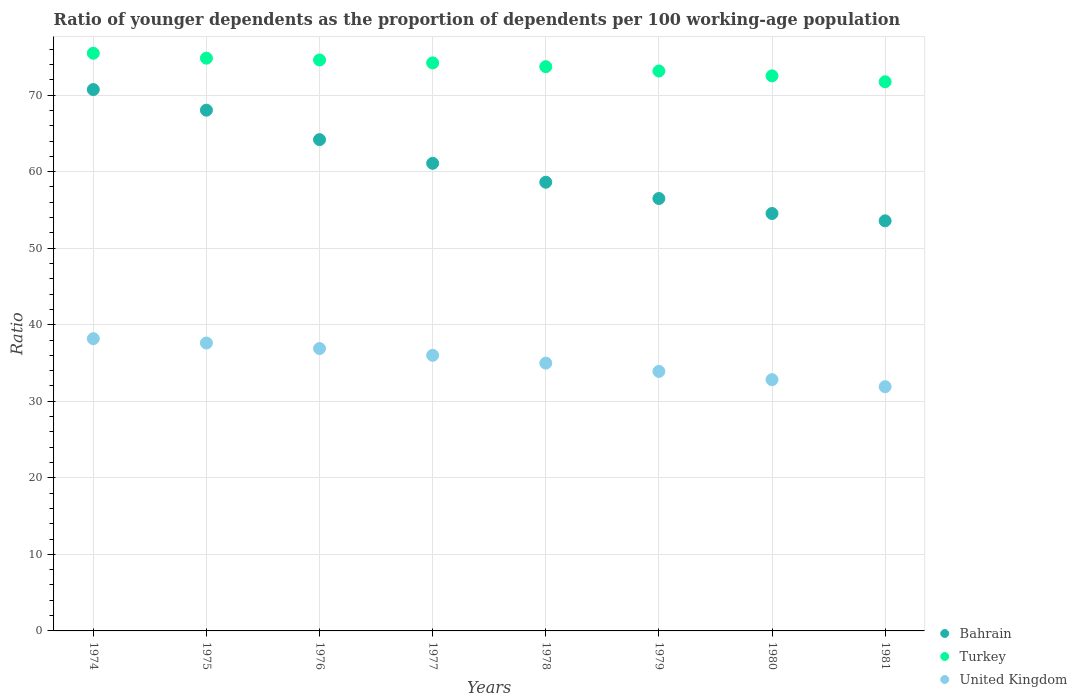How many different coloured dotlines are there?
Ensure brevity in your answer.  3. What is the age dependency ratio(young) in United Kingdom in 1981?
Make the answer very short. 31.91. Across all years, what is the maximum age dependency ratio(young) in Bahrain?
Provide a succinct answer. 70.73. Across all years, what is the minimum age dependency ratio(young) in Bahrain?
Ensure brevity in your answer.  53.58. In which year was the age dependency ratio(young) in Bahrain maximum?
Your answer should be compact. 1974. What is the total age dependency ratio(young) in Turkey in the graph?
Make the answer very short. 590.27. What is the difference between the age dependency ratio(young) in Turkey in 1976 and that in 1978?
Offer a very short reply. 0.87. What is the difference between the age dependency ratio(young) in United Kingdom in 1975 and the age dependency ratio(young) in Bahrain in 1977?
Your answer should be compact. -23.48. What is the average age dependency ratio(young) in Turkey per year?
Keep it short and to the point. 73.78. In the year 1981, what is the difference between the age dependency ratio(young) in Bahrain and age dependency ratio(young) in United Kingdom?
Your answer should be very brief. 21.67. What is the ratio of the age dependency ratio(young) in United Kingdom in 1975 to that in 1981?
Your answer should be compact. 1.18. Is the age dependency ratio(young) in United Kingdom in 1978 less than that in 1980?
Your response must be concise. No. What is the difference between the highest and the second highest age dependency ratio(young) in Turkey?
Offer a terse response. 0.64. What is the difference between the highest and the lowest age dependency ratio(young) in Bahrain?
Provide a short and direct response. 17.15. Is it the case that in every year, the sum of the age dependency ratio(young) in Turkey and age dependency ratio(young) in Bahrain  is greater than the age dependency ratio(young) in United Kingdom?
Provide a short and direct response. Yes. Does the age dependency ratio(young) in United Kingdom monotonically increase over the years?
Your answer should be very brief. No. Is the age dependency ratio(young) in Turkey strictly less than the age dependency ratio(young) in United Kingdom over the years?
Provide a short and direct response. No. How many dotlines are there?
Provide a short and direct response. 3. What is the difference between two consecutive major ticks on the Y-axis?
Your response must be concise. 10. Are the values on the major ticks of Y-axis written in scientific E-notation?
Make the answer very short. No. Where does the legend appear in the graph?
Your answer should be very brief. Bottom right. What is the title of the graph?
Make the answer very short. Ratio of younger dependents as the proportion of dependents per 100 working-age population. What is the label or title of the X-axis?
Ensure brevity in your answer.  Years. What is the label or title of the Y-axis?
Your answer should be compact. Ratio. What is the Ratio of Bahrain in 1974?
Your response must be concise. 70.73. What is the Ratio in Turkey in 1974?
Your answer should be very brief. 75.48. What is the Ratio in United Kingdom in 1974?
Make the answer very short. 38.18. What is the Ratio of Bahrain in 1975?
Provide a succinct answer. 68.04. What is the Ratio in Turkey in 1975?
Ensure brevity in your answer.  74.83. What is the Ratio of United Kingdom in 1975?
Provide a short and direct response. 37.62. What is the Ratio in Bahrain in 1976?
Your answer should be very brief. 64.19. What is the Ratio of Turkey in 1976?
Offer a terse response. 74.6. What is the Ratio of United Kingdom in 1976?
Your answer should be compact. 36.89. What is the Ratio of Bahrain in 1977?
Your answer should be very brief. 61.09. What is the Ratio in Turkey in 1977?
Offer a terse response. 74.21. What is the Ratio in United Kingdom in 1977?
Offer a very short reply. 36.01. What is the Ratio in Bahrain in 1978?
Your response must be concise. 58.62. What is the Ratio in Turkey in 1978?
Offer a terse response. 73.72. What is the Ratio of United Kingdom in 1978?
Offer a terse response. 34.99. What is the Ratio of Bahrain in 1979?
Provide a succinct answer. 56.5. What is the Ratio in Turkey in 1979?
Ensure brevity in your answer.  73.16. What is the Ratio of United Kingdom in 1979?
Your response must be concise. 33.9. What is the Ratio of Bahrain in 1980?
Give a very brief answer. 54.54. What is the Ratio of Turkey in 1980?
Give a very brief answer. 72.52. What is the Ratio of United Kingdom in 1980?
Offer a terse response. 32.83. What is the Ratio in Bahrain in 1981?
Provide a succinct answer. 53.58. What is the Ratio of Turkey in 1981?
Your answer should be compact. 71.75. What is the Ratio in United Kingdom in 1981?
Provide a short and direct response. 31.91. Across all years, what is the maximum Ratio in Bahrain?
Keep it short and to the point. 70.73. Across all years, what is the maximum Ratio in Turkey?
Provide a succinct answer. 75.48. Across all years, what is the maximum Ratio in United Kingdom?
Make the answer very short. 38.18. Across all years, what is the minimum Ratio of Bahrain?
Provide a short and direct response. 53.58. Across all years, what is the minimum Ratio of Turkey?
Your response must be concise. 71.75. Across all years, what is the minimum Ratio in United Kingdom?
Give a very brief answer. 31.91. What is the total Ratio in Bahrain in the graph?
Offer a terse response. 487.29. What is the total Ratio in Turkey in the graph?
Offer a very short reply. 590.27. What is the total Ratio of United Kingdom in the graph?
Offer a very short reply. 282.34. What is the difference between the Ratio in Bahrain in 1974 and that in 1975?
Your answer should be compact. 2.69. What is the difference between the Ratio of Turkey in 1974 and that in 1975?
Provide a succinct answer. 0.64. What is the difference between the Ratio of United Kingdom in 1974 and that in 1975?
Offer a terse response. 0.57. What is the difference between the Ratio in Bahrain in 1974 and that in 1976?
Provide a short and direct response. 6.54. What is the difference between the Ratio in Turkey in 1974 and that in 1976?
Ensure brevity in your answer.  0.88. What is the difference between the Ratio of United Kingdom in 1974 and that in 1976?
Keep it short and to the point. 1.29. What is the difference between the Ratio of Bahrain in 1974 and that in 1977?
Provide a short and direct response. 9.64. What is the difference between the Ratio of Turkey in 1974 and that in 1977?
Provide a succinct answer. 1.26. What is the difference between the Ratio of United Kingdom in 1974 and that in 1977?
Keep it short and to the point. 2.17. What is the difference between the Ratio of Bahrain in 1974 and that in 1978?
Ensure brevity in your answer.  12.11. What is the difference between the Ratio in Turkey in 1974 and that in 1978?
Offer a terse response. 1.75. What is the difference between the Ratio in United Kingdom in 1974 and that in 1978?
Make the answer very short. 3.19. What is the difference between the Ratio of Bahrain in 1974 and that in 1979?
Your answer should be compact. 14.24. What is the difference between the Ratio of Turkey in 1974 and that in 1979?
Ensure brevity in your answer.  2.32. What is the difference between the Ratio of United Kingdom in 1974 and that in 1979?
Your answer should be compact. 4.28. What is the difference between the Ratio in Bahrain in 1974 and that in 1980?
Your answer should be very brief. 16.19. What is the difference between the Ratio in Turkey in 1974 and that in 1980?
Your answer should be compact. 2.95. What is the difference between the Ratio of United Kingdom in 1974 and that in 1980?
Make the answer very short. 5.35. What is the difference between the Ratio in Bahrain in 1974 and that in 1981?
Offer a terse response. 17.15. What is the difference between the Ratio of Turkey in 1974 and that in 1981?
Your response must be concise. 3.73. What is the difference between the Ratio of United Kingdom in 1974 and that in 1981?
Your response must be concise. 6.28. What is the difference between the Ratio of Bahrain in 1975 and that in 1976?
Offer a very short reply. 3.85. What is the difference between the Ratio of Turkey in 1975 and that in 1976?
Your response must be concise. 0.23. What is the difference between the Ratio of United Kingdom in 1975 and that in 1976?
Provide a succinct answer. 0.72. What is the difference between the Ratio of Bahrain in 1975 and that in 1977?
Offer a terse response. 6.94. What is the difference between the Ratio of Turkey in 1975 and that in 1977?
Your answer should be compact. 0.62. What is the difference between the Ratio of United Kingdom in 1975 and that in 1977?
Ensure brevity in your answer.  1.6. What is the difference between the Ratio in Bahrain in 1975 and that in 1978?
Provide a succinct answer. 9.41. What is the difference between the Ratio in Turkey in 1975 and that in 1978?
Provide a short and direct response. 1.11. What is the difference between the Ratio of United Kingdom in 1975 and that in 1978?
Keep it short and to the point. 2.63. What is the difference between the Ratio in Bahrain in 1975 and that in 1979?
Offer a very short reply. 11.54. What is the difference between the Ratio of Turkey in 1975 and that in 1979?
Ensure brevity in your answer.  1.67. What is the difference between the Ratio in United Kingdom in 1975 and that in 1979?
Make the answer very short. 3.71. What is the difference between the Ratio in Bahrain in 1975 and that in 1980?
Make the answer very short. 13.5. What is the difference between the Ratio in Turkey in 1975 and that in 1980?
Your answer should be compact. 2.31. What is the difference between the Ratio in United Kingdom in 1975 and that in 1980?
Ensure brevity in your answer.  4.79. What is the difference between the Ratio in Bahrain in 1975 and that in 1981?
Your answer should be very brief. 14.46. What is the difference between the Ratio of Turkey in 1975 and that in 1981?
Offer a very short reply. 3.08. What is the difference between the Ratio of United Kingdom in 1975 and that in 1981?
Your answer should be compact. 5.71. What is the difference between the Ratio of Bahrain in 1976 and that in 1977?
Give a very brief answer. 3.09. What is the difference between the Ratio of Turkey in 1976 and that in 1977?
Your response must be concise. 0.38. What is the difference between the Ratio in United Kingdom in 1976 and that in 1977?
Provide a succinct answer. 0.88. What is the difference between the Ratio in Bahrain in 1976 and that in 1978?
Your answer should be very brief. 5.56. What is the difference between the Ratio of Turkey in 1976 and that in 1978?
Provide a short and direct response. 0.87. What is the difference between the Ratio in United Kingdom in 1976 and that in 1978?
Make the answer very short. 1.9. What is the difference between the Ratio of Bahrain in 1976 and that in 1979?
Your answer should be compact. 7.69. What is the difference between the Ratio in Turkey in 1976 and that in 1979?
Offer a very short reply. 1.44. What is the difference between the Ratio of United Kingdom in 1976 and that in 1979?
Provide a short and direct response. 2.99. What is the difference between the Ratio of Bahrain in 1976 and that in 1980?
Make the answer very short. 9.65. What is the difference between the Ratio in Turkey in 1976 and that in 1980?
Make the answer very short. 2.08. What is the difference between the Ratio of United Kingdom in 1976 and that in 1980?
Make the answer very short. 4.06. What is the difference between the Ratio of Bahrain in 1976 and that in 1981?
Give a very brief answer. 10.61. What is the difference between the Ratio of Turkey in 1976 and that in 1981?
Offer a terse response. 2.85. What is the difference between the Ratio of United Kingdom in 1976 and that in 1981?
Ensure brevity in your answer.  4.99. What is the difference between the Ratio in Bahrain in 1977 and that in 1978?
Your answer should be very brief. 2.47. What is the difference between the Ratio of Turkey in 1977 and that in 1978?
Give a very brief answer. 0.49. What is the difference between the Ratio of United Kingdom in 1977 and that in 1978?
Give a very brief answer. 1.02. What is the difference between the Ratio of Bahrain in 1977 and that in 1979?
Your answer should be very brief. 4.6. What is the difference between the Ratio in Turkey in 1977 and that in 1979?
Your answer should be very brief. 1.06. What is the difference between the Ratio in United Kingdom in 1977 and that in 1979?
Your answer should be very brief. 2.11. What is the difference between the Ratio in Bahrain in 1977 and that in 1980?
Offer a very short reply. 6.56. What is the difference between the Ratio in Turkey in 1977 and that in 1980?
Your answer should be very brief. 1.69. What is the difference between the Ratio in United Kingdom in 1977 and that in 1980?
Ensure brevity in your answer.  3.18. What is the difference between the Ratio in Bahrain in 1977 and that in 1981?
Keep it short and to the point. 7.51. What is the difference between the Ratio in Turkey in 1977 and that in 1981?
Offer a very short reply. 2.46. What is the difference between the Ratio of United Kingdom in 1977 and that in 1981?
Provide a short and direct response. 4.1. What is the difference between the Ratio of Bahrain in 1978 and that in 1979?
Your response must be concise. 2.13. What is the difference between the Ratio in Turkey in 1978 and that in 1979?
Keep it short and to the point. 0.57. What is the difference between the Ratio in United Kingdom in 1978 and that in 1979?
Give a very brief answer. 1.09. What is the difference between the Ratio of Bahrain in 1978 and that in 1980?
Offer a very short reply. 4.09. What is the difference between the Ratio in Turkey in 1978 and that in 1980?
Keep it short and to the point. 1.2. What is the difference between the Ratio in United Kingdom in 1978 and that in 1980?
Provide a succinct answer. 2.16. What is the difference between the Ratio of Bahrain in 1978 and that in 1981?
Make the answer very short. 5.04. What is the difference between the Ratio of Turkey in 1978 and that in 1981?
Your answer should be very brief. 1.97. What is the difference between the Ratio of United Kingdom in 1978 and that in 1981?
Provide a succinct answer. 3.08. What is the difference between the Ratio of Bahrain in 1979 and that in 1980?
Provide a short and direct response. 1.96. What is the difference between the Ratio of Turkey in 1979 and that in 1980?
Offer a very short reply. 0.64. What is the difference between the Ratio of United Kingdom in 1979 and that in 1980?
Provide a succinct answer. 1.07. What is the difference between the Ratio in Bahrain in 1979 and that in 1981?
Your answer should be compact. 2.91. What is the difference between the Ratio in Turkey in 1979 and that in 1981?
Give a very brief answer. 1.41. What is the difference between the Ratio in United Kingdom in 1979 and that in 1981?
Provide a succinct answer. 2. What is the difference between the Ratio in Bahrain in 1980 and that in 1981?
Your response must be concise. 0.96. What is the difference between the Ratio in Turkey in 1980 and that in 1981?
Your response must be concise. 0.77. What is the difference between the Ratio in United Kingdom in 1980 and that in 1981?
Provide a short and direct response. 0.92. What is the difference between the Ratio of Bahrain in 1974 and the Ratio of Turkey in 1975?
Ensure brevity in your answer.  -4.1. What is the difference between the Ratio in Bahrain in 1974 and the Ratio in United Kingdom in 1975?
Provide a succinct answer. 33.12. What is the difference between the Ratio of Turkey in 1974 and the Ratio of United Kingdom in 1975?
Keep it short and to the point. 37.86. What is the difference between the Ratio in Bahrain in 1974 and the Ratio in Turkey in 1976?
Offer a very short reply. -3.87. What is the difference between the Ratio of Bahrain in 1974 and the Ratio of United Kingdom in 1976?
Provide a succinct answer. 33.84. What is the difference between the Ratio in Turkey in 1974 and the Ratio in United Kingdom in 1976?
Make the answer very short. 38.58. What is the difference between the Ratio of Bahrain in 1974 and the Ratio of Turkey in 1977?
Your answer should be compact. -3.48. What is the difference between the Ratio of Bahrain in 1974 and the Ratio of United Kingdom in 1977?
Provide a short and direct response. 34.72. What is the difference between the Ratio in Turkey in 1974 and the Ratio in United Kingdom in 1977?
Give a very brief answer. 39.46. What is the difference between the Ratio of Bahrain in 1974 and the Ratio of Turkey in 1978?
Offer a very short reply. -2.99. What is the difference between the Ratio of Bahrain in 1974 and the Ratio of United Kingdom in 1978?
Offer a terse response. 35.74. What is the difference between the Ratio of Turkey in 1974 and the Ratio of United Kingdom in 1978?
Your answer should be very brief. 40.48. What is the difference between the Ratio of Bahrain in 1974 and the Ratio of Turkey in 1979?
Provide a succinct answer. -2.42. What is the difference between the Ratio in Bahrain in 1974 and the Ratio in United Kingdom in 1979?
Your answer should be very brief. 36.83. What is the difference between the Ratio in Turkey in 1974 and the Ratio in United Kingdom in 1979?
Keep it short and to the point. 41.57. What is the difference between the Ratio of Bahrain in 1974 and the Ratio of Turkey in 1980?
Offer a very short reply. -1.79. What is the difference between the Ratio in Bahrain in 1974 and the Ratio in United Kingdom in 1980?
Provide a short and direct response. 37.9. What is the difference between the Ratio of Turkey in 1974 and the Ratio of United Kingdom in 1980?
Your answer should be very brief. 42.65. What is the difference between the Ratio in Bahrain in 1974 and the Ratio in Turkey in 1981?
Provide a short and direct response. -1.02. What is the difference between the Ratio of Bahrain in 1974 and the Ratio of United Kingdom in 1981?
Offer a terse response. 38.82. What is the difference between the Ratio of Turkey in 1974 and the Ratio of United Kingdom in 1981?
Make the answer very short. 43.57. What is the difference between the Ratio in Bahrain in 1975 and the Ratio in Turkey in 1976?
Provide a succinct answer. -6.56. What is the difference between the Ratio of Bahrain in 1975 and the Ratio of United Kingdom in 1976?
Give a very brief answer. 31.15. What is the difference between the Ratio of Turkey in 1975 and the Ratio of United Kingdom in 1976?
Your answer should be compact. 37.94. What is the difference between the Ratio of Bahrain in 1975 and the Ratio of Turkey in 1977?
Keep it short and to the point. -6.17. What is the difference between the Ratio in Bahrain in 1975 and the Ratio in United Kingdom in 1977?
Provide a short and direct response. 32.03. What is the difference between the Ratio in Turkey in 1975 and the Ratio in United Kingdom in 1977?
Offer a terse response. 38.82. What is the difference between the Ratio in Bahrain in 1975 and the Ratio in Turkey in 1978?
Ensure brevity in your answer.  -5.68. What is the difference between the Ratio of Bahrain in 1975 and the Ratio of United Kingdom in 1978?
Ensure brevity in your answer.  33.05. What is the difference between the Ratio of Turkey in 1975 and the Ratio of United Kingdom in 1978?
Give a very brief answer. 39.84. What is the difference between the Ratio of Bahrain in 1975 and the Ratio of Turkey in 1979?
Give a very brief answer. -5.12. What is the difference between the Ratio in Bahrain in 1975 and the Ratio in United Kingdom in 1979?
Your answer should be very brief. 34.13. What is the difference between the Ratio in Turkey in 1975 and the Ratio in United Kingdom in 1979?
Your response must be concise. 40.93. What is the difference between the Ratio of Bahrain in 1975 and the Ratio of Turkey in 1980?
Your response must be concise. -4.48. What is the difference between the Ratio in Bahrain in 1975 and the Ratio in United Kingdom in 1980?
Keep it short and to the point. 35.21. What is the difference between the Ratio of Turkey in 1975 and the Ratio of United Kingdom in 1980?
Ensure brevity in your answer.  42. What is the difference between the Ratio in Bahrain in 1975 and the Ratio in Turkey in 1981?
Make the answer very short. -3.71. What is the difference between the Ratio in Bahrain in 1975 and the Ratio in United Kingdom in 1981?
Provide a short and direct response. 36.13. What is the difference between the Ratio of Turkey in 1975 and the Ratio of United Kingdom in 1981?
Your answer should be very brief. 42.92. What is the difference between the Ratio of Bahrain in 1976 and the Ratio of Turkey in 1977?
Give a very brief answer. -10.03. What is the difference between the Ratio of Bahrain in 1976 and the Ratio of United Kingdom in 1977?
Provide a short and direct response. 28.18. What is the difference between the Ratio in Turkey in 1976 and the Ratio in United Kingdom in 1977?
Your answer should be compact. 38.59. What is the difference between the Ratio of Bahrain in 1976 and the Ratio of Turkey in 1978?
Make the answer very short. -9.53. What is the difference between the Ratio in Bahrain in 1976 and the Ratio in United Kingdom in 1978?
Offer a very short reply. 29.2. What is the difference between the Ratio in Turkey in 1976 and the Ratio in United Kingdom in 1978?
Your answer should be compact. 39.61. What is the difference between the Ratio of Bahrain in 1976 and the Ratio of Turkey in 1979?
Your response must be concise. -8.97. What is the difference between the Ratio of Bahrain in 1976 and the Ratio of United Kingdom in 1979?
Keep it short and to the point. 30.28. What is the difference between the Ratio of Turkey in 1976 and the Ratio of United Kingdom in 1979?
Offer a terse response. 40.69. What is the difference between the Ratio in Bahrain in 1976 and the Ratio in Turkey in 1980?
Offer a terse response. -8.33. What is the difference between the Ratio in Bahrain in 1976 and the Ratio in United Kingdom in 1980?
Provide a short and direct response. 31.36. What is the difference between the Ratio of Turkey in 1976 and the Ratio of United Kingdom in 1980?
Provide a short and direct response. 41.77. What is the difference between the Ratio in Bahrain in 1976 and the Ratio in Turkey in 1981?
Your answer should be very brief. -7.56. What is the difference between the Ratio in Bahrain in 1976 and the Ratio in United Kingdom in 1981?
Ensure brevity in your answer.  32.28. What is the difference between the Ratio in Turkey in 1976 and the Ratio in United Kingdom in 1981?
Your answer should be very brief. 42.69. What is the difference between the Ratio of Bahrain in 1977 and the Ratio of Turkey in 1978?
Your answer should be compact. -12.63. What is the difference between the Ratio of Bahrain in 1977 and the Ratio of United Kingdom in 1978?
Your response must be concise. 26.1. What is the difference between the Ratio of Turkey in 1977 and the Ratio of United Kingdom in 1978?
Your response must be concise. 39.22. What is the difference between the Ratio in Bahrain in 1977 and the Ratio in Turkey in 1979?
Provide a short and direct response. -12.06. What is the difference between the Ratio of Bahrain in 1977 and the Ratio of United Kingdom in 1979?
Your answer should be very brief. 27.19. What is the difference between the Ratio of Turkey in 1977 and the Ratio of United Kingdom in 1979?
Give a very brief answer. 40.31. What is the difference between the Ratio of Bahrain in 1977 and the Ratio of Turkey in 1980?
Ensure brevity in your answer.  -11.43. What is the difference between the Ratio in Bahrain in 1977 and the Ratio in United Kingdom in 1980?
Provide a succinct answer. 28.26. What is the difference between the Ratio in Turkey in 1977 and the Ratio in United Kingdom in 1980?
Give a very brief answer. 41.38. What is the difference between the Ratio of Bahrain in 1977 and the Ratio of Turkey in 1981?
Ensure brevity in your answer.  -10.66. What is the difference between the Ratio of Bahrain in 1977 and the Ratio of United Kingdom in 1981?
Give a very brief answer. 29.19. What is the difference between the Ratio of Turkey in 1977 and the Ratio of United Kingdom in 1981?
Your answer should be very brief. 42.31. What is the difference between the Ratio of Bahrain in 1978 and the Ratio of Turkey in 1979?
Ensure brevity in your answer.  -14.53. What is the difference between the Ratio in Bahrain in 1978 and the Ratio in United Kingdom in 1979?
Keep it short and to the point. 24.72. What is the difference between the Ratio of Turkey in 1978 and the Ratio of United Kingdom in 1979?
Make the answer very short. 39.82. What is the difference between the Ratio of Bahrain in 1978 and the Ratio of Turkey in 1980?
Make the answer very short. -13.9. What is the difference between the Ratio in Bahrain in 1978 and the Ratio in United Kingdom in 1980?
Give a very brief answer. 25.79. What is the difference between the Ratio of Turkey in 1978 and the Ratio of United Kingdom in 1980?
Provide a short and direct response. 40.89. What is the difference between the Ratio of Bahrain in 1978 and the Ratio of Turkey in 1981?
Ensure brevity in your answer.  -13.13. What is the difference between the Ratio in Bahrain in 1978 and the Ratio in United Kingdom in 1981?
Ensure brevity in your answer.  26.72. What is the difference between the Ratio in Turkey in 1978 and the Ratio in United Kingdom in 1981?
Ensure brevity in your answer.  41.81. What is the difference between the Ratio of Bahrain in 1979 and the Ratio of Turkey in 1980?
Your answer should be very brief. -16.02. What is the difference between the Ratio of Bahrain in 1979 and the Ratio of United Kingdom in 1980?
Keep it short and to the point. 23.67. What is the difference between the Ratio of Turkey in 1979 and the Ratio of United Kingdom in 1980?
Keep it short and to the point. 40.33. What is the difference between the Ratio in Bahrain in 1979 and the Ratio in Turkey in 1981?
Your response must be concise. -15.25. What is the difference between the Ratio of Bahrain in 1979 and the Ratio of United Kingdom in 1981?
Provide a short and direct response. 24.59. What is the difference between the Ratio in Turkey in 1979 and the Ratio in United Kingdom in 1981?
Offer a very short reply. 41.25. What is the difference between the Ratio of Bahrain in 1980 and the Ratio of Turkey in 1981?
Give a very brief answer. -17.21. What is the difference between the Ratio in Bahrain in 1980 and the Ratio in United Kingdom in 1981?
Provide a short and direct response. 22.63. What is the difference between the Ratio in Turkey in 1980 and the Ratio in United Kingdom in 1981?
Provide a succinct answer. 40.61. What is the average Ratio of Bahrain per year?
Offer a terse response. 60.91. What is the average Ratio in Turkey per year?
Your answer should be compact. 73.78. What is the average Ratio in United Kingdom per year?
Provide a short and direct response. 35.29. In the year 1974, what is the difference between the Ratio in Bahrain and Ratio in Turkey?
Keep it short and to the point. -4.74. In the year 1974, what is the difference between the Ratio of Bahrain and Ratio of United Kingdom?
Your answer should be compact. 32.55. In the year 1974, what is the difference between the Ratio in Turkey and Ratio in United Kingdom?
Your answer should be compact. 37.29. In the year 1975, what is the difference between the Ratio of Bahrain and Ratio of Turkey?
Offer a terse response. -6.79. In the year 1975, what is the difference between the Ratio in Bahrain and Ratio in United Kingdom?
Your answer should be compact. 30.42. In the year 1975, what is the difference between the Ratio of Turkey and Ratio of United Kingdom?
Provide a succinct answer. 37.22. In the year 1976, what is the difference between the Ratio of Bahrain and Ratio of Turkey?
Your answer should be compact. -10.41. In the year 1976, what is the difference between the Ratio of Bahrain and Ratio of United Kingdom?
Make the answer very short. 27.3. In the year 1976, what is the difference between the Ratio of Turkey and Ratio of United Kingdom?
Offer a terse response. 37.7. In the year 1977, what is the difference between the Ratio of Bahrain and Ratio of Turkey?
Your answer should be compact. -13.12. In the year 1977, what is the difference between the Ratio in Bahrain and Ratio in United Kingdom?
Offer a very short reply. 25.08. In the year 1977, what is the difference between the Ratio of Turkey and Ratio of United Kingdom?
Offer a very short reply. 38.2. In the year 1978, what is the difference between the Ratio of Bahrain and Ratio of Turkey?
Ensure brevity in your answer.  -15.1. In the year 1978, what is the difference between the Ratio in Bahrain and Ratio in United Kingdom?
Your answer should be compact. 23.63. In the year 1978, what is the difference between the Ratio in Turkey and Ratio in United Kingdom?
Keep it short and to the point. 38.73. In the year 1979, what is the difference between the Ratio of Bahrain and Ratio of Turkey?
Your response must be concise. -16.66. In the year 1979, what is the difference between the Ratio in Bahrain and Ratio in United Kingdom?
Your answer should be very brief. 22.59. In the year 1979, what is the difference between the Ratio in Turkey and Ratio in United Kingdom?
Your answer should be very brief. 39.25. In the year 1980, what is the difference between the Ratio in Bahrain and Ratio in Turkey?
Offer a terse response. -17.98. In the year 1980, what is the difference between the Ratio of Bahrain and Ratio of United Kingdom?
Your response must be concise. 21.71. In the year 1980, what is the difference between the Ratio of Turkey and Ratio of United Kingdom?
Give a very brief answer. 39.69. In the year 1981, what is the difference between the Ratio in Bahrain and Ratio in Turkey?
Make the answer very short. -18.17. In the year 1981, what is the difference between the Ratio in Bahrain and Ratio in United Kingdom?
Offer a very short reply. 21.67. In the year 1981, what is the difference between the Ratio in Turkey and Ratio in United Kingdom?
Your answer should be compact. 39.84. What is the ratio of the Ratio of Bahrain in 1974 to that in 1975?
Offer a very short reply. 1.04. What is the ratio of the Ratio in Turkey in 1974 to that in 1975?
Ensure brevity in your answer.  1.01. What is the ratio of the Ratio of United Kingdom in 1974 to that in 1975?
Give a very brief answer. 1.02. What is the ratio of the Ratio of Bahrain in 1974 to that in 1976?
Make the answer very short. 1.1. What is the ratio of the Ratio of Turkey in 1974 to that in 1976?
Provide a short and direct response. 1.01. What is the ratio of the Ratio of United Kingdom in 1974 to that in 1976?
Offer a terse response. 1.03. What is the ratio of the Ratio in Bahrain in 1974 to that in 1977?
Ensure brevity in your answer.  1.16. What is the ratio of the Ratio of United Kingdom in 1974 to that in 1977?
Offer a terse response. 1.06. What is the ratio of the Ratio of Bahrain in 1974 to that in 1978?
Offer a very short reply. 1.21. What is the ratio of the Ratio in Turkey in 1974 to that in 1978?
Provide a short and direct response. 1.02. What is the ratio of the Ratio of United Kingdom in 1974 to that in 1978?
Keep it short and to the point. 1.09. What is the ratio of the Ratio in Bahrain in 1974 to that in 1979?
Offer a terse response. 1.25. What is the ratio of the Ratio in Turkey in 1974 to that in 1979?
Ensure brevity in your answer.  1.03. What is the ratio of the Ratio in United Kingdom in 1974 to that in 1979?
Your answer should be compact. 1.13. What is the ratio of the Ratio in Bahrain in 1974 to that in 1980?
Ensure brevity in your answer.  1.3. What is the ratio of the Ratio of Turkey in 1974 to that in 1980?
Keep it short and to the point. 1.04. What is the ratio of the Ratio in United Kingdom in 1974 to that in 1980?
Give a very brief answer. 1.16. What is the ratio of the Ratio in Bahrain in 1974 to that in 1981?
Your answer should be compact. 1.32. What is the ratio of the Ratio of Turkey in 1974 to that in 1981?
Your answer should be compact. 1.05. What is the ratio of the Ratio of United Kingdom in 1974 to that in 1981?
Your response must be concise. 1.2. What is the ratio of the Ratio in Bahrain in 1975 to that in 1976?
Your answer should be compact. 1.06. What is the ratio of the Ratio of Turkey in 1975 to that in 1976?
Your answer should be very brief. 1. What is the ratio of the Ratio of United Kingdom in 1975 to that in 1976?
Make the answer very short. 1.02. What is the ratio of the Ratio of Bahrain in 1975 to that in 1977?
Offer a terse response. 1.11. What is the ratio of the Ratio in Turkey in 1975 to that in 1977?
Offer a terse response. 1.01. What is the ratio of the Ratio in United Kingdom in 1975 to that in 1977?
Your answer should be very brief. 1.04. What is the ratio of the Ratio in Bahrain in 1975 to that in 1978?
Your answer should be very brief. 1.16. What is the ratio of the Ratio of United Kingdom in 1975 to that in 1978?
Ensure brevity in your answer.  1.07. What is the ratio of the Ratio in Bahrain in 1975 to that in 1979?
Keep it short and to the point. 1.2. What is the ratio of the Ratio in Turkey in 1975 to that in 1979?
Your answer should be compact. 1.02. What is the ratio of the Ratio in United Kingdom in 1975 to that in 1979?
Give a very brief answer. 1.11. What is the ratio of the Ratio in Bahrain in 1975 to that in 1980?
Your answer should be compact. 1.25. What is the ratio of the Ratio of Turkey in 1975 to that in 1980?
Give a very brief answer. 1.03. What is the ratio of the Ratio in United Kingdom in 1975 to that in 1980?
Provide a succinct answer. 1.15. What is the ratio of the Ratio in Bahrain in 1975 to that in 1981?
Keep it short and to the point. 1.27. What is the ratio of the Ratio of Turkey in 1975 to that in 1981?
Your response must be concise. 1.04. What is the ratio of the Ratio in United Kingdom in 1975 to that in 1981?
Your answer should be very brief. 1.18. What is the ratio of the Ratio in Bahrain in 1976 to that in 1977?
Offer a very short reply. 1.05. What is the ratio of the Ratio of Turkey in 1976 to that in 1977?
Provide a succinct answer. 1.01. What is the ratio of the Ratio in United Kingdom in 1976 to that in 1977?
Make the answer very short. 1.02. What is the ratio of the Ratio in Bahrain in 1976 to that in 1978?
Your response must be concise. 1.09. What is the ratio of the Ratio of Turkey in 1976 to that in 1978?
Your answer should be compact. 1.01. What is the ratio of the Ratio of United Kingdom in 1976 to that in 1978?
Your answer should be compact. 1.05. What is the ratio of the Ratio in Bahrain in 1976 to that in 1979?
Keep it short and to the point. 1.14. What is the ratio of the Ratio of Turkey in 1976 to that in 1979?
Make the answer very short. 1.02. What is the ratio of the Ratio of United Kingdom in 1976 to that in 1979?
Make the answer very short. 1.09. What is the ratio of the Ratio in Bahrain in 1976 to that in 1980?
Your response must be concise. 1.18. What is the ratio of the Ratio of Turkey in 1976 to that in 1980?
Your answer should be compact. 1.03. What is the ratio of the Ratio of United Kingdom in 1976 to that in 1980?
Your answer should be very brief. 1.12. What is the ratio of the Ratio in Bahrain in 1976 to that in 1981?
Provide a succinct answer. 1.2. What is the ratio of the Ratio of Turkey in 1976 to that in 1981?
Offer a terse response. 1.04. What is the ratio of the Ratio in United Kingdom in 1976 to that in 1981?
Give a very brief answer. 1.16. What is the ratio of the Ratio of Bahrain in 1977 to that in 1978?
Your response must be concise. 1.04. What is the ratio of the Ratio of Turkey in 1977 to that in 1978?
Your response must be concise. 1.01. What is the ratio of the Ratio in United Kingdom in 1977 to that in 1978?
Offer a very short reply. 1.03. What is the ratio of the Ratio in Bahrain in 1977 to that in 1979?
Provide a short and direct response. 1.08. What is the ratio of the Ratio in Turkey in 1977 to that in 1979?
Offer a very short reply. 1.01. What is the ratio of the Ratio in United Kingdom in 1977 to that in 1979?
Offer a very short reply. 1.06. What is the ratio of the Ratio of Bahrain in 1977 to that in 1980?
Ensure brevity in your answer.  1.12. What is the ratio of the Ratio in Turkey in 1977 to that in 1980?
Your response must be concise. 1.02. What is the ratio of the Ratio in United Kingdom in 1977 to that in 1980?
Give a very brief answer. 1.1. What is the ratio of the Ratio in Bahrain in 1977 to that in 1981?
Offer a terse response. 1.14. What is the ratio of the Ratio of Turkey in 1977 to that in 1981?
Provide a short and direct response. 1.03. What is the ratio of the Ratio of United Kingdom in 1977 to that in 1981?
Offer a very short reply. 1.13. What is the ratio of the Ratio of Bahrain in 1978 to that in 1979?
Your response must be concise. 1.04. What is the ratio of the Ratio in Turkey in 1978 to that in 1979?
Give a very brief answer. 1.01. What is the ratio of the Ratio of United Kingdom in 1978 to that in 1979?
Keep it short and to the point. 1.03. What is the ratio of the Ratio in Bahrain in 1978 to that in 1980?
Your answer should be very brief. 1.07. What is the ratio of the Ratio in Turkey in 1978 to that in 1980?
Keep it short and to the point. 1.02. What is the ratio of the Ratio of United Kingdom in 1978 to that in 1980?
Provide a succinct answer. 1.07. What is the ratio of the Ratio of Bahrain in 1978 to that in 1981?
Your response must be concise. 1.09. What is the ratio of the Ratio in Turkey in 1978 to that in 1981?
Offer a very short reply. 1.03. What is the ratio of the Ratio in United Kingdom in 1978 to that in 1981?
Your answer should be very brief. 1.1. What is the ratio of the Ratio of Bahrain in 1979 to that in 1980?
Provide a short and direct response. 1.04. What is the ratio of the Ratio of Turkey in 1979 to that in 1980?
Provide a short and direct response. 1.01. What is the ratio of the Ratio of United Kingdom in 1979 to that in 1980?
Ensure brevity in your answer.  1.03. What is the ratio of the Ratio in Bahrain in 1979 to that in 1981?
Offer a terse response. 1.05. What is the ratio of the Ratio in Turkey in 1979 to that in 1981?
Your answer should be very brief. 1.02. What is the ratio of the Ratio of United Kingdom in 1979 to that in 1981?
Make the answer very short. 1.06. What is the ratio of the Ratio of Bahrain in 1980 to that in 1981?
Your response must be concise. 1.02. What is the ratio of the Ratio in Turkey in 1980 to that in 1981?
Ensure brevity in your answer.  1.01. What is the ratio of the Ratio in United Kingdom in 1980 to that in 1981?
Give a very brief answer. 1.03. What is the difference between the highest and the second highest Ratio in Bahrain?
Provide a short and direct response. 2.69. What is the difference between the highest and the second highest Ratio of Turkey?
Your response must be concise. 0.64. What is the difference between the highest and the second highest Ratio of United Kingdom?
Make the answer very short. 0.57. What is the difference between the highest and the lowest Ratio of Bahrain?
Provide a succinct answer. 17.15. What is the difference between the highest and the lowest Ratio in Turkey?
Keep it short and to the point. 3.73. What is the difference between the highest and the lowest Ratio of United Kingdom?
Provide a short and direct response. 6.28. 